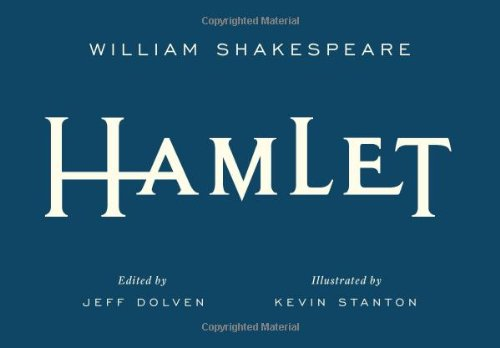Is this book related to Literature & Fiction? Yes, 'Hamlet' is fundamentally a significant piece of Literature & Fiction, focusing on complex themes of treachery, revenge, incest, and moral corruption. 